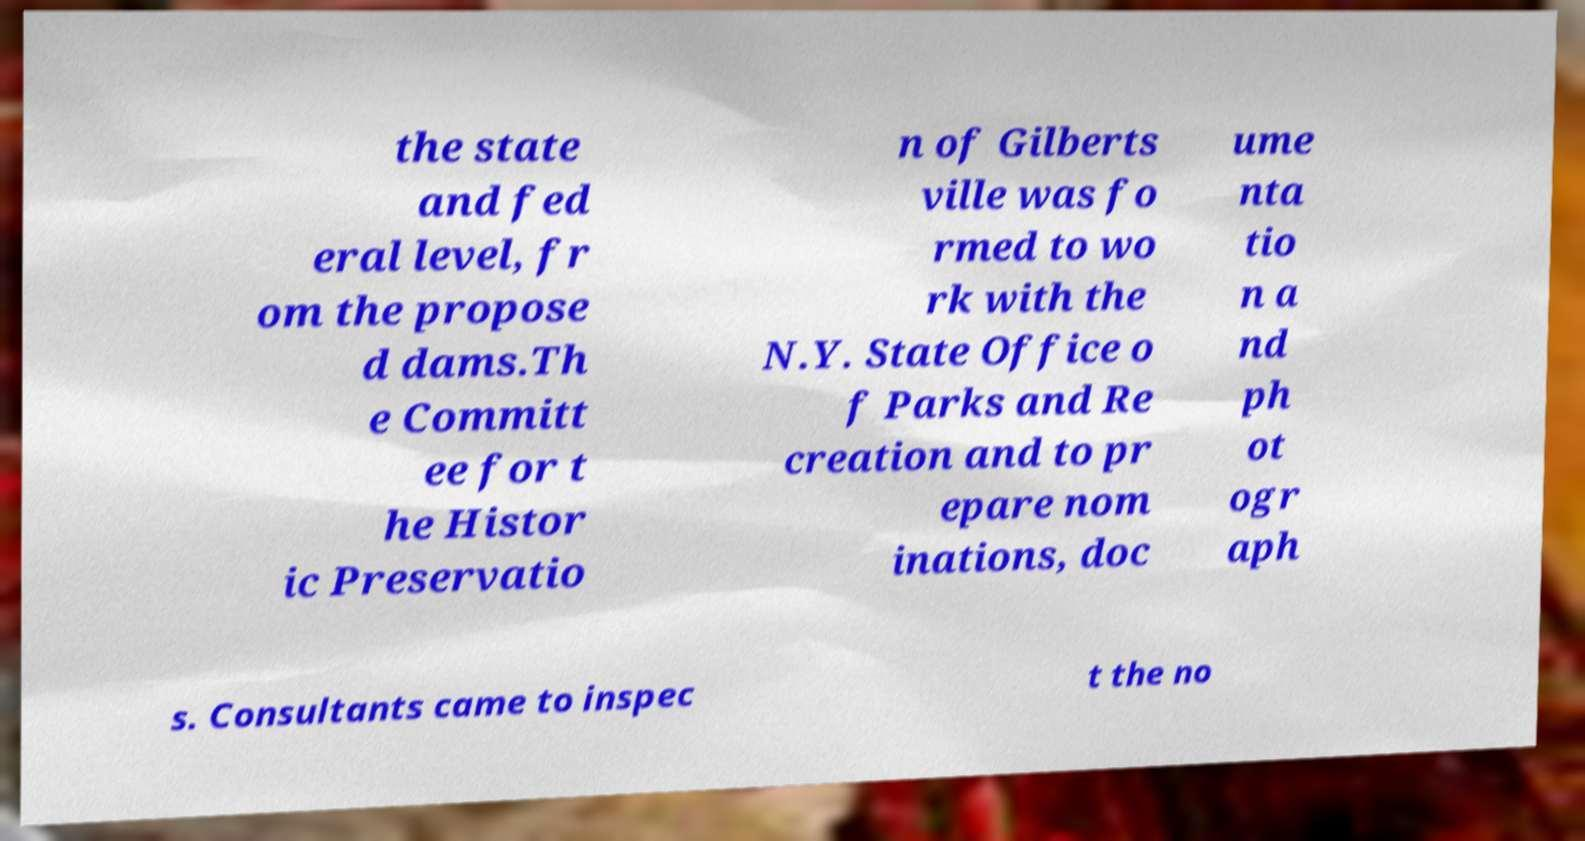I need the written content from this picture converted into text. Can you do that? the state and fed eral level, fr om the propose d dams.Th e Committ ee for t he Histor ic Preservatio n of Gilberts ville was fo rmed to wo rk with the N.Y. State Office o f Parks and Re creation and to pr epare nom inations, doc ume nta tio n a nd ph ot ogr aph s. Consultants came to inspec t the no 